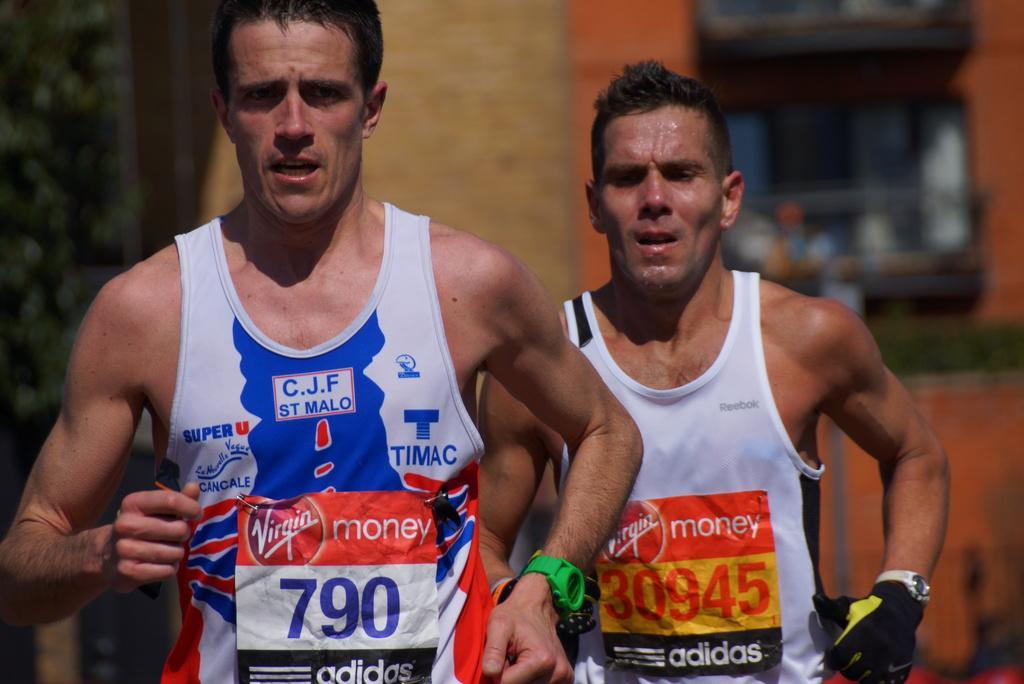Can you describe this image briefly? In this picture in the front there are persons running and there is some text and there are some numbers written on the clothes of the persons. In the background there are trees and there is a building and there is a fence and background seems to be blurred. 